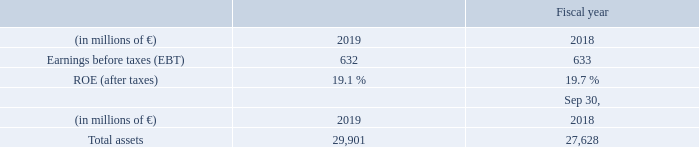A.3.8 Financial Services
Financial Services supports its customers’ investments with leasing solutions and equipment, project and structured financing in the form of debt and equity investments. Based on its comprehensive financing know-how and specialist technology expertise in
the areas of Siemens businesses, Financial Services provides financial
solutions for Siemens customers as well as other companies.
Financial Services again delivered strong earnings before taxes. While the equity business recorded higher results, the result from the debt business declined, amongst others due to higher credit hits. Total assets increased along with a growth in debt business and in part due to positive currency translation effects.
Financial Services is geared to Siemens’ industrial businesses and its markets. As such Financial Services is influenced by the business development of the markets served by our industrial businesses, among other factors. Financial Services will continue to focus its business scope on areas of intense domain know-how.
What caused the Total assets to increase? Total assets increased along with a growth in debt business and in part due to positive currency translation effects. How did the equity and debt businesses reacted to the credit hits? While the equity business recorded higher results, the result from the debt business declined, amongst others due to higher credit hits. total assets increased along with a growth in debt business and in part due to positive currency translation effects. What is the scope of Financial services business? Financial services will continue to focus its business scope on areas of intense domain know-how. What is the increase / (decrease) in the Earnings before taxes from 2018 to 2019?
Answer scale should be: million. 632 - 633
Answer: -1. What is the average total assets in 2018 and 2019?
Answer scale should be: million. (29,901 + 27,628) / 2
Answer: 28764.5. What is the increase / (decrease) in the ROE(after taxes) from 2018 to 2019?
Answer scale should be: percent. 19.1% - 19.7%
Answer: -0.6. 